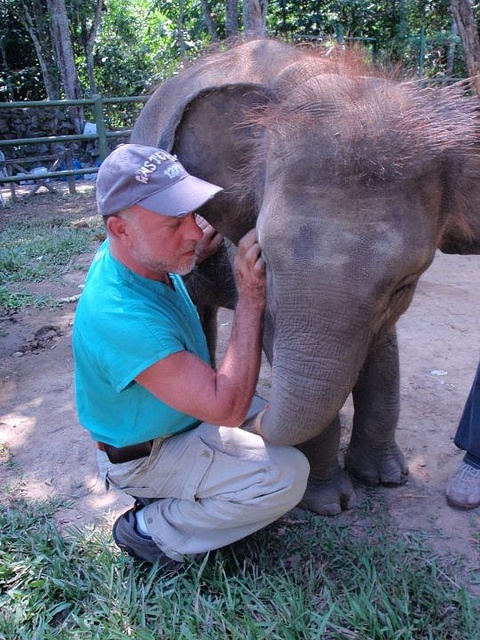Describe the objects in this image and their specific colors. I can see elephant in darkblue, gray, black, and darkgray tones, people in darkblue, gray, brown, lightblue, and darkgray tones, people in darkblue, navy, and gray tones, and bench in darkblue, gray, navy, and black tones in this image. 